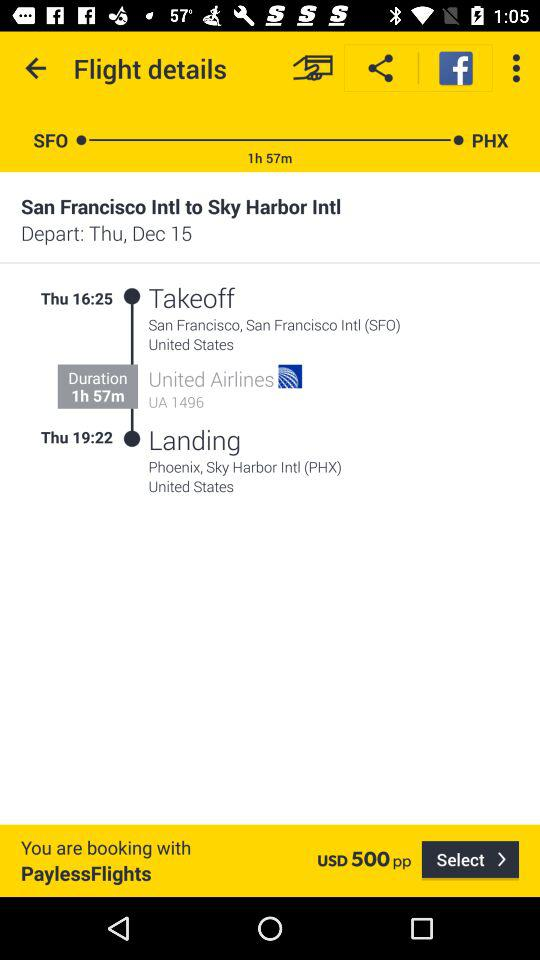At what time will the flight take off? The flight will take off at 16:25. 